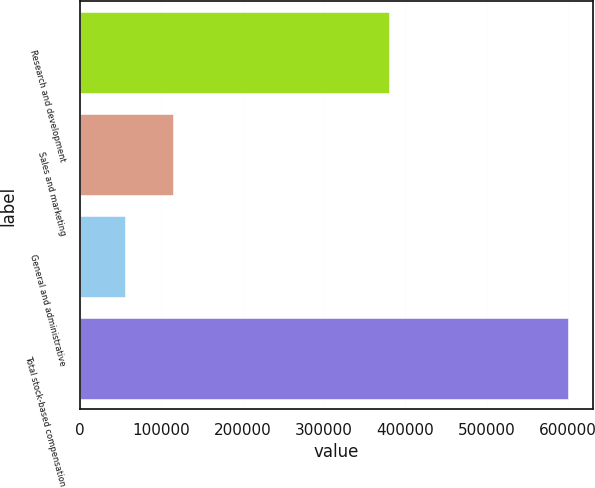Convert chart to OTSL. <chart><loc_0><loc_0><loc_500><loc_500><bar_chart><fcel>Research and development<fcel>Sales and marketing<fcel>General and administrative<fcel>Total stock-based compensation<nl><fcel>379913<fcel>114440<fcel>55072<fcel>600367<nl></chart> 